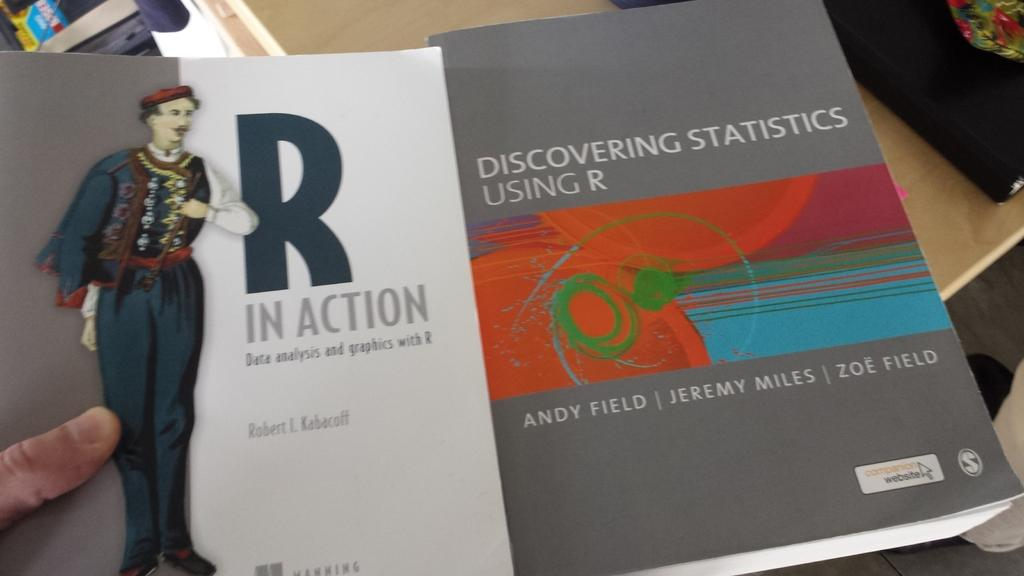<image>
Share a concise interpretation of the image provided. Two books about statistics for using and discovering R 